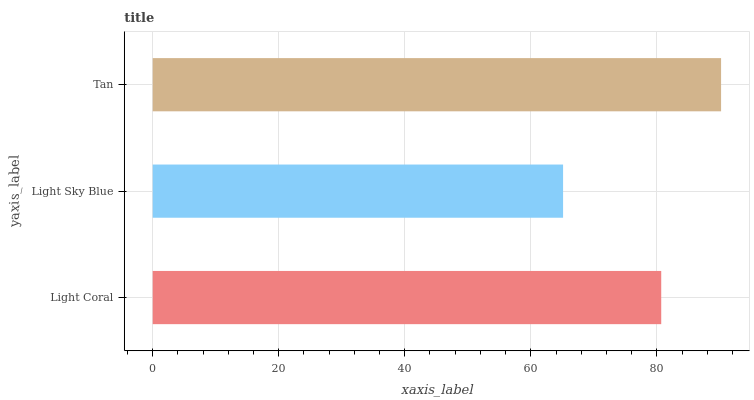Is Light Sky Blue the minimum?
Answer yes or no. Yes. Is Tan the maximum?
Answer yes or no. Yes. Is Tan the minimum?
Answer yes or no. No. Is Light Sky Blue the maximum?
Answer yes or no. No. Is Tan greater than Light Sky Blue?
Answer yes or no. Yes. Is Light Sky Blue less than Tan?
Answer yes or no. Yes. Is Light Sky Blue greater than Tan?
Answer yes or no. No. Is Tan less than Light Sky Blue?
Answer yes or no. No. Is Light Coral the high median?
Answer yes or no. Yes. Is Light Coral the low median?
Answer yes or no. Yes. Is Tan the high median?
Answer yes or no. No. Is Light Sky Blue the low median?
Answer yes or no. No. 